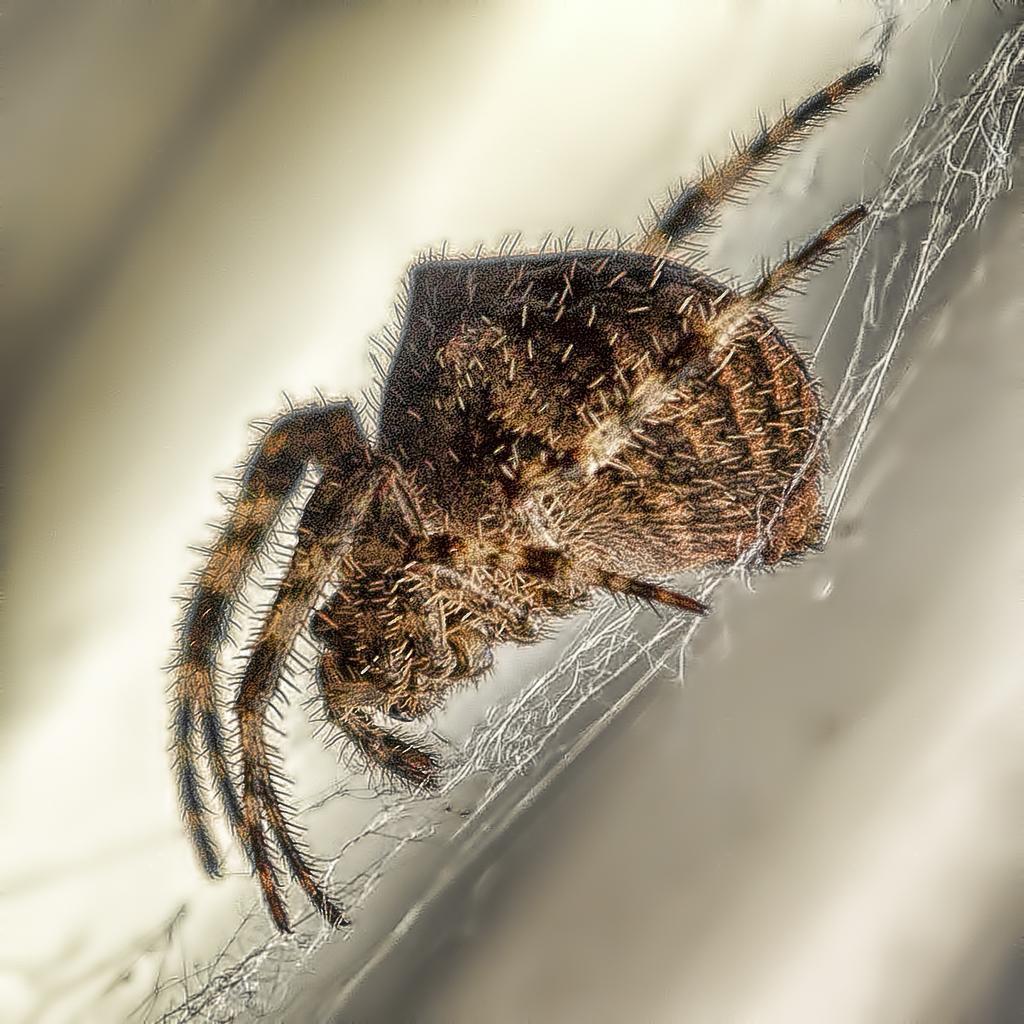Describe this image in one or two sentences. In this image we can see a spider on the web. 